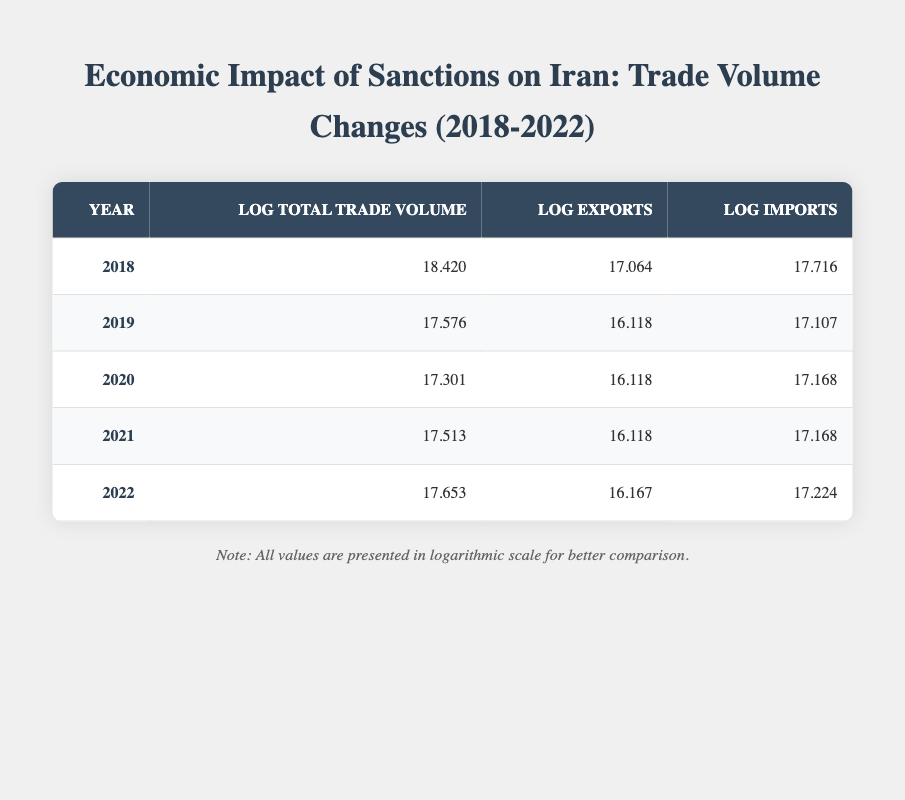What was the total trade volume in 2018? According to the table, the total trade volume for the year 2018 is specified as 100000000.
Answer: 100000000 What is the log of imports for 2022? The log of imports for 2022 can be directly found in the table, listed under the "Log Imports" column for that year, which is 17.224.
Answer: 17.224 Which year had the highest log total trade volume? By examining the "Log Total Trade Volume" column, 2018 has the highest value at 18.420 compared to other years.
Answer: 2018 What was the difference in log exports between 2021 and 2020? The table shows that for 2021 the log exports are 16.118 and for 2020 they are also 16.118. Therefore, the difference is 16.118 - 16.118 = 0.
Answer: 0 Did Iran's total trade volume increase every year from 2018 to 2022? By looking at the "Total Trade Volume" over the years, it increased from 100000000 in 2018 to 70000000 in 2022. There was a decrease in 2019 and 2020, thus the statement is false.
Answer: No 